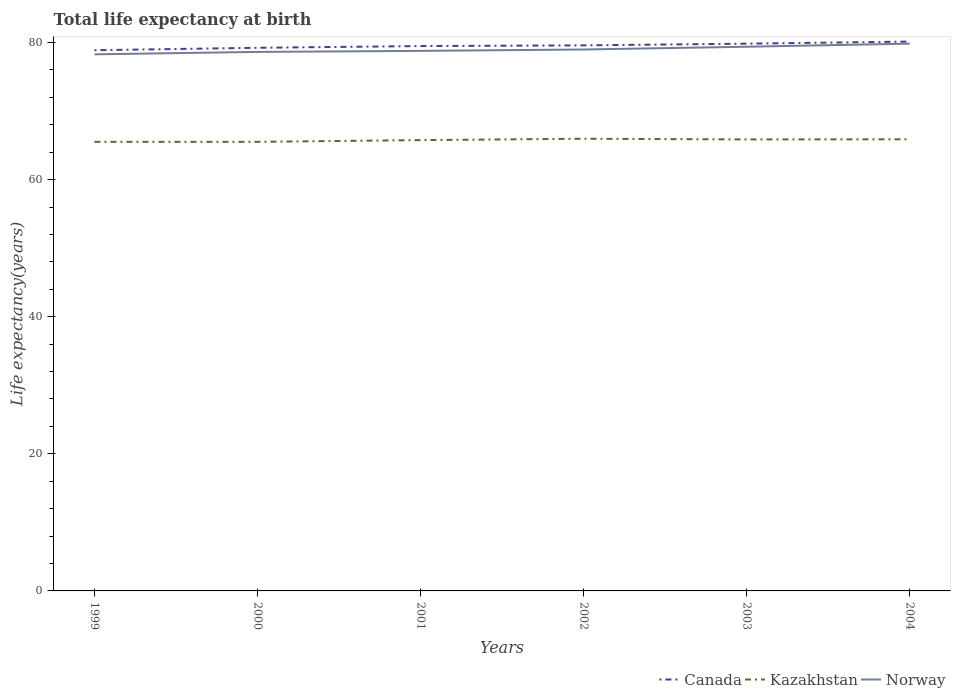Across all years, what is the maximum life expectancy at birth in in Kazakhstan?
Provide a succinct answer. 65.52. In which year was the life expectancy at birth in in Kazakhstan maximum?
Make the answer very short. 2000. What is the total life expectancy at birth in in Norway in the graph?
Provide a short and direct response. -0.15. What is the difference between the highest and the second highest life expectancy at birth in in Kazakhstan?
Your answer should be compact. 0.45. What is the difference between the highest and the lowest life expectancy at birth in in Kazakhstan?
Your response must be concise. 4. How many lines are there?
Your answer should be compact. 3. What is the difference between two consecutive major ticks on the Y-axis?
Make the answer very short. 20. Are the values on the major ticks of Y-axis written in scientific E-notation?
Ensure brevity in your answer.  No. Does the graph contain any zero values?
Your response must be concise. No. Does the graph contain grids?
Keep it short and to the point. No. How many legend labels are there?
Your response must be concise. 3. How are the legend labels stacked?
Offer a terse response. Horizontal. What is the title of the graph?
Make the answer very short. Total life expectancy at birth. Does "Korea (Republic)" appear as one of the legend labels in the graph?
Provide a succinct answer. No. What is the label or title of the Y-axis?
Make the answer very short. Life expectancy(years). What is the Life expectancy(years) of Canada in 1999?
Your answer should be compact. 78.88. What is the Life expectancy(years) in Kazakhstan in 1999?
Offer a very short reply. 65.52. What is the Life expectancy(years) of Norway in 1999?
Your answer should be compact. 78.28. What is the Life expectancy(years) in Canada in 2000?
Ensure brevity in your answer.  79.24. What is the Life expectancy(years) of Kazakhstan in 2000?
Offer a very short reply. 65.52. What is the Life expectancy(years) in Norway in 2000?
Make the answer very short. 78.63. What is the Life expectancy(years) in Canada in 2001?
Provide a succinct answer. 79.49. What is the Life expectancy(years) in Kazakhstan in 2001?
Offer a very short reply. 65.77. What is the Life expectancy(years) of Norway in 2001?
Your answer should be very brief. 78.79. What is the Life expectancy(years) of Canada in 2002?
Your response must be concise. 79.59. What is the Life expectancy(years) in Kazakhstan in 2002?
Ensure brevity in your answer.  65.97. What is the Life expectancy(years) in Norway in 2002?
Give a very brief answer. 78.99. What is the Life expectancy(years) of Canada in 2003?
Your answer should be compact. 79.84. What is the Life expectancy(years) in Kazakhstan in 2003?
Your response must be concise. 65.87. What is the Life expectancy(years) of Norway in 2003?
Your response must be concise. 79.39. What is the Life expectancy(years) in Canada in 2004?
Ensure brevity in your answer.  80.14. What is the Life expectancy(years) of Kazakhstan in 2004?
Offer a very short reply. 65.89. What is the Life expectancy(years) of Norway in 2004?
Provide a succinct answer. 79.84. Across all years, what is the maximum Life expectancy(years) of Canada?
Offer a terse response. 80.14. Across all years, what is the maximum Life expectancy(years) of Kazakhstan?
Offer a very short reply. 65.97. Across all years, what is the maximum Life expectancy(years) of Norway?
Your answer should be compact. 79.84. Across all years, what is the minimum Life expectancy(years) in Canada?
Provide a short and direct response. 78.88. Across all years, what is the minimum Life expectancy(years) in Kazakhstan?
Offer a terse response. 65.52. Across all years, what is the minimum Life expectancy(years) of Norway?
Ensure brevity in your answer.  78.28. What is the total Life expectancy(years) of Canada in the graph?
Offer a very short reply. 477.18. What is the total Life expectancy(years) of Kazakhstan in the graph?
Your answer should be very brief. 394.53. What is the total Life expectancy(years) of Norway in the graph?
Your response must be concise. 473.92. What is the difference between the Life expectancy(years) of Canada in 1999 and that in 2000?
Your answer should be compact. -0.35. What is the difference between the Life expectancy(years) of Kazakhstan in 1999 and that in 2000?
Keep it short and to the point. 0. What is the difference between the Life expectancy(years) in Norway in 1999 and that in 2000?
Provide a succinct answer. -0.35. What is the difference between the Life expectancy(years) in Canada in 1999 and that in 2001?
Your answer should be very brief. -0.6. What is the difference between the Life expectancy(years) of Kazakhstan in 1999 and that in 2001?
Make the answer very short. -0.25. What is the difference between the Life expectancy(years) in Norway in 1999 and that in 2001?
Offer a terse response. -0.5. What is the difference between the Life expectancy(years) of Canada in 1999 and that in 2002?
Make the answer very short. -0.71. What is the difference between the Life expectancy(years) of Kazakhstan in 1999 and that in 2002?
Provide a succinct answer. -0.45. What is the difference between the Life expectancy(years) in Norway in 1999 and that in 2002?
Give a very brief answer. -0.7. What is the difference between the Life expectancy(years) in Canada in 1999 and that in 2003?
Your answer should be compact. -0.96. What is the difference between the Life expectancy(years) in Kazakhstan in 1999 and that in 2003?
Your answer should be compact. -0.35. What is the difference between the Life expectancy(years) of Norway in 1999 and that in 2003?
Your answer should be compact. -1.11. What is the difference between the Life expectancy(years) of Canada in 1999 and that in 2004?
Ensure brevity in your answer.  -1.26. What is the difference between the Life expectancy(years) in Kazakhstan in 1999 and that in 2004?
Keep it short and to the point. -0.37. What is the difference between the Life expectancy(years) of Norway in 1999 and that in 2004?
Offer a terse response. -1.56. What is the difference between the Life expectancy(years) of Canada in 2000 and that in 2001?
Offer a terse response. -0.25. What is the difference between the Life expectancy(years) in Kazakhstan in 2000 and that in 2001?
Ensure brevity in your answer.  -0.25. What is the difference between the Life expectancy(years) of Norway in 2000 and that in 2001?
Ensure brevity in your answer.  -0.15. What is the difference between the Life expectancy(years) in Canada in 2000 and that in 2002?
Keep it short and to the point. -0.35. What is the difference between the Life expectancy(years) of Kazakhstan in 2000 and that in 2002?
Offer a very short reply. -0.45. What is the difference between the Life expectancy(years) in Norway in 2000 and that in 2002?
Keep it short and to the point. -0.35. What is the difference between the Life expectancy(years) in Canada in 2000 and that in 2003?
Ensure brevity in your answer.  -0.6. What is the difference between the Life expectancy(years) in Kazakhstan in 2000 and that in 2003?
Ensure brevity in your answer.  -0.35. What is the difference between the Life expectancy(years) in Norway in 2000 and that in 2003?
Offer a terse response. -0.76. What is the difference between the Life expectancy(years) of Canada in 2000 and that in 2004?
Provide a short and direct response. -0.9. What is the difference between the Life expectancy(years) of Kazakhstan in 2000 and that in 2004?
Keep it short and to the point. -0.37. What is the difference between the Life expectancy(years) of Norway in 2000 and that in 2004?
Ensure brevity in your answer.  -1.21. What is the difference between the Life expectancy(years) in Canada in 2001 and that in 2002?
Offer a very short reply. -0.1. What is the difference between the Life expectancy(years) in Norway in 2001 and that in 2002?
Your response must be concise. -0.2. What is the difference between the Life expectancy(years) of Canada in 2001 and that in 2003?
Give a very brief answer. -0.35. What is the difference between the Life expectancy(years) in Kazakhstan in 2001 and that in 2003?
Provide a succinct answer. -0.1. What is the difference between the Life expectancy(years) of Norway in 2001 and that in 2003?
Ensure brevity in your answer.  -0.6. What is the difference between the Life expectancy(years) in Canada in 2001 and that in 2004?
Provide a short and direct response. -0.65. What is the difference between the Life expectancy(years) of Kazakhstan in 2001 and that in 2004?
Give a very brief answer. -0.12. What is the difference between the Life expectancy(years) of Norway in 2001 and that in 2004?
Ensure brevity in your answer.  -1.06. What is the difference between the Life expectancy(years) in Canada in 2002 and that in 2003?
Keep it short and to the point. -0.25. What is the difference between the Life expectancy(years) of Kazakhstan in 2002 and that in 2003?
Offer a terse response. 0.1. What is the difference between the Life expectancy(years) in Norway in 2002 and that in 2003?
Ensure brevity in your answer.  -0.4. What is the difference between the Life expectancy(years) of Canada in 2002 and that in 2004?
Provide a short and direct response. -0.55. What is the difference between the Life expectancy(years) of Kazakhstan in 2002 and that in 2004?
Provide a succinct answer. 0.08. What is the difference between the Life expectancy(years) in Norway in 2002 and that in 2004?
Make the answer very short. -0.85. What is the difference between the Life expectancy(years) of Canada in 2003 and that in 2004?
Provide a succinct answer. -0.3. What is the difference between the Life expectancy(years) in Kazakhstan in 2003 and that in 2004?
Provide a succinct answer. -0.02. What is the difference between the Life expectancy(years) of Norway in 2003 and that in 2004?
Keep it short and to the point. -0.45. What is the difference between the Life expectancy(years) in Canada in 1999 and the Life expectancy(years) in Kazakhstan in 2000?
Provide a short and direct response. 13.37. What is the difference between the Life expectancy(years) in Canada in 1999 and the Life expectancy(years) in Norway in 2000?
Provide a short and direct response. 0.25. What is the difference between the Life expectancy(years) in Kazakhstan in 1999 and the Life expectancy(years) in Norway in 2000?
Ensure brevity in your answer.  -13.11. What is the difference between the Life expectancy(years) of Canada in 1999 and the Life expectancy(years) of Kazakhstan in 2001?
Provide a succinct answer. 13.11. What is the difference between the Life expectancy(years) of Canada in 1999 and the Life expectancy(years) of Norway in 2001?
Keep it short and to the point. 0.1. What is the difference between the Life expectancy(years) in Kazakhstan in 1999 and the Life expectancy(years) in Norway in 2001?
Provide a succinct answer. -13.27. What is the difference between the Life expectancy(years) in Canada in 1999 and the Life expectancy(years) in Kazakhstan in 2002?
Give a very brief answer. 12.91. What is the difference between the Life expectancy(years) in Canada in 1999 and the Life expectancy(years) in Norway in 2002?
Offer a terse response. -0.1. What is the difference between the Life expectancy(years) in Kazakhstan in 1999 and the Life expectancy(years) in Norway in 2002?
Provide a short and direct response. -13.47. What is the difference between the Life expectancy(years) in Canada in 1999 and the Life expectancy(years) in Kazakhstan in 2003?
Offer a very short reply. 13.02. What is the difference between the Life expectancy(years) of Canada in 1999 and the Life expectancy(years) of Norway in 2003?
Keep it short and to the point. -0.51. What is the difference between the Life expectancy(years) of Kazakhstan in 1999 and the Life expectancy(years) of Norway in 2003?
Provide a succinct answer. -13.87. What is the difference between the Life expectancy(years) in Canada in 1999 and the Life expectancy(years) in Kazakhstan in 2004?
Provide a succinct answer. 13. What is the difference between the Life expectancy(years) in Canada in 1999 and the Life expectancy(years) in Norway in 2004?
Provide a short and direct response. -0.96. What is the difference between the Life expectancy(years) in Kazakhstan in 1999 and the Life expectancy(years) in Norway in 2004?
Ensure brevity in your answer.  -14.32. What is the difference between the Life expectancy(years) of Canada in 2000 and the Life expectancy(years) of Kazakhstan in 2001?
Keep it short and to the point. 13.47. What is the difference between the Life expectancy(years) in Canada in 2000 and the Life expectancy(years) in Norway in 2001?
Make the answer very short. 0.45. What is the difference between the Life expectancy(years) of Kazakhstan in 2000 and the Life expectancy(years) of Norway in 2001?
Your answer should be compact. -13.27. What is the difference between the Life expectancy(years) in Canada in 2000 and the Life expectancy(years) in Kazakhstan in 2002?
Ensure brevity in your answer.  13.27. What is the difference between the Life expectancy(years) in Canada in 2000 and the Life expectancy(years) in Norway in 2002?
Provide a succinct answer. 0.25. What is the difference between the Life expectancy(years) in Kazakhstan in 2000 and the Life expectancy(years) in Norway in 2002?
Give a very brief answer. -13.47. What is the difference between the Life expectancy(years) in Canada in 2000 and the Life expectancy(years) in Kazakhstan in 2003?
Make the answer very short. 13.37. What is the difference between the Life expectancy(years) in Canada in 2000 and the Life expectancy(years) in Norway in 2003?
Provide a short and direct response. -0.15. What is the difference between the Life expectancy(years) of Kazakhstan in 2000 and the Life expectancy(years) of Norway in 2003?
Keep it short and to the point. -13.87. What is the difference between the Life expectancy(years) of Canada in 2000 and the Life expectancy(years) of Kazakhstan in 2004?
Keep it short and to the point. 13.35. What is the difference between the Life expectancy(years) of Canada in 2000 and the Life expectancy(years) of Norway in 2004?
Offer a terse response. -0.6. What is the difference between the Life expectancy(years) of Kazakhstan in 2000 and the Life expectancy(years) of Norway in 2004?
Provide a short and direct response. -14.32. What is the difference between the Life expectancy(years) of Canada in 2001 and the Life expectancy(years) of Kazakhstan in 2002?
Offer a very short reply. 13.52. What is the difference between the Life expectancy(years) of Canada in 2001 and the Life expectancy(years) of Norway in 2002?
Make the answer very short. 0.5. What is the difference between the Life expectancy(years) in Kazakhstan in 2001 and the Life expectancy(years) in Norway in 2002?
Keep it short and to the point. -13.22. What is the difference between the Life expectancy(years) of Canada in 2001 and the Life expectancy(years) of Kazakhstan in 2003?
Offer a very short reply. 13.62. What is the difference between the Life expectancy(years) of Canada in 2001 and the Life expectancy(years) of Norway in 2003?
Offer a terse response. 0.1. What is the difference between the Life expectancy(years) of Kazakhstan in 2001 and the Life expectancy(years) of Norway in 2003?
Ensure brevity in your answer.  -13.62. What is the difference between the Life expectancy(years) in Canada in 2001 and the Life expectancy(years) in Norway in 2004?
Give a very brief answer. -0.35. What is the difference between the Life expectancy(years) in Kazakhstan in 2001 and the Life expectancy(years) in Norway in 2004?
Offer a very short reply. -14.07. What is the difference between the Life expectancy(years) of Canada in 2002 and the Life expectancy(years) of Kazakhstan in 2003?
Your response must be concise. 13.72. What is the difference between the Life expectancy(years) of Canada in 2002 and the Life expectancy(years) of Norway in 2003?
Provide a succinct answer. 0.2. What is the difference between the Life expectancy(years) of Kazakhstan in 2002 and the Life expectancy(years) of Norway in 2003?
Keep it short and to the point. -13.42. What is the difference between the Life expectancy(years) of Canada in 2002 and the Life expectancy(years) of Kazakhstan in 2004?
Offer a very short reply. 13.7. What is the difference between the Life expectancy(years) in Canada in 2002 and the Life expectancy(years) in Norway in 2004?
Your response must be concise. -0.25. What is the difference between the Life expectancy(years) in Kazakhstan in 2002 and the Life expectancy(years) in Norway in 2004?
Offer a terse response. -13.87. What is the difference between the Life expectancy(years) of Canada in 2003 and the Life expectancy(years) of Kazakhstan in 2004?
Make the answer very short. 13.95. What is the difference between the Life expectancy(years) of Canada in 2003 and the Life expectancy(years) of Norway in 2004?
Offer a very short reply. -0. What is the difference between the Life expectancy(years) of Kazakhstan in 2003 and the Life expectancy(years) of Norway in 2004?
Your answer should be compact. -13.98. What is the average Life expectancy(years) of Canada per year?
Your answer should be compact. 79.53. What is the average Life expectancy(years) in Kazakhstan per year?
Offer a very short reply. 65.75. What is the average Life expectancy(years) in Norway per year?
Offer a terse response. 78.99. In the year 1999, what is the difference between the Life expectancy(years) in Canada and Life expectancy(years) in Kazakhstan?
Make the answer very short. 13.36. In the year 1999, what is the difference between the Life expectancy(years) in Canada and Life expectancy(years) in Norway?
Give a very brief answer. 0.6. In the year 1999, what is the difference between the Life expectancy(years) of Kazakhstan and Life expectancy(years) of Norway?
Offer a terse response. -12.76. In the year 2000, what is the difference between the Life expectancy(years) in Canada and Life expectancy(years) in Kazakhstan?
Give a very brief answer. 13.72. In the year 2000, what is the difference between the Life expectancy(years) of Canada and Life expectancy(years) of Norway?
Offer a very short reply. 0.6. In the year 2000, what is the difference between the Life expectancy(years) in Kazakhstan and Life expectancy(years) in Norway?
Offer a very short reply. -13.12. In the year 2001, what is the difference between the Life expectancy(years) in Canada and Life expectancy(years) in Kazakhstan?
Provide a succinct answer. 13.72. In the year 2001, what is the difference between the Life expectancy(years) in Canada and Life expectancy(years) in Norway?
Give a very brief answer. 0.7. In the year 2001, what is the difference between the Life expectancy(years) of Kazakhstan and Life expectancy(years) of Norway?
Make the answer very short. -13.02. In the year 2002, what is the difference between the Life expectancy(years) of Canada and Life expectancy(years) of Kazakhstan?
Your answer should be very brief. 13.62. In the year 2002, what is the difference between the Life expectancy(years) in Canada and Life expectancy(years) in Norway?
Offer a very short reply. 0.6. In the year 2002, what is the difference between the Life expectancy(years) of Kazakhstan and Life expectancy(years) of Norway?
Your answer should be compact. -13.02. In the year 2003, what is the difference between the Life expectancy(years) of Canada and Life expectancy(years) of Kazakhstan?
Your answer should be very brief. 13.97. In the year 2003, what is the difference between the Life expectancy(years) of Canada and Life expectancy(years) of Norway?
Offer a very short reply. 0.45. In the year 2003, what is the difference between the Life expectancy(years) of Kazakhstan and Life expectancy(years) of Norway?
Offer a very short reply. -13.52. In the year 2004, what is the difference between the Life expectancy(years) in Canada and Life expectancy(years) in Kazakhstan?
Your answer should be very brief. 14.25. In the year 2004, what is the difference between the Life expectancy(years) in Canada and Life expectancy(years) in Norway?
Your response must be concise. 0.3. In the year 2004, what is the difference between the Life expectancy(years) of Kazakhstan and Life expectancy(years) of Norway?
Ensure brevity in your answer.  -13.95. What is the ratio of the Life expectancy(years) in Kazakhstan in 1999 to that in 2000?
Give a very brief answer. 1. What is the ratio of the Life expectancy(years) in Canada in 1999 to that in 2001?
Offer a very short reply. 0.99. What is the ratio of the Life expectancy(years) in Norway in 1999 to that in 2001?
Provide a succinct answer. 0.99. What is the ratio of the Life expectancy(years) in Norway in 1999 to that in 2002?
Offer a terse response. 0.99. What is the ratio of the Life expectancy(years) of Norway in 1999 to that in 2003?
Give a very brief answer. 0.99. What is the ratio of the Life expectancy(years) of Canada in 1999 to that in 2004?
Your answer should be very brief. 0.98. What is the ratio of the Life expectancy(years) of Kazakhstan in 1999 to that in 2004?
Your answer should be compact. 0.99. What is the ratio of the Life expectancy(years) in Norway in 1999 to that in 2004?
Your answer should be very brief. 0.98. What is the ratio of the Life expectancy(years) in Canada in 2000 to that in 2001?
Give a very brief answer. 1. What is the ratio of the Life expectancy(years) in Kazakhstan in 2000 to that in 2002?
Ensure brevity in your answer.  0.99. What is the ratio of the Life expectancy(years) of Norway in 2000 to that in 2002?
Keep it short and to the point. 1. What is the ratio of the Life expectancy(years) of Canada in 2000 to that in 2003?
Provide a short and direct response. 0.99. What is the ratio of the Life expectancy(years) in Canada in 2000 to that in 2004?
Make the answer very short. 0.99. What is the ratio of the Life expectancy(years) in Kazakhstan in 2000 to that in 2004?
Your response must be concise. 0.99. What is the ratio of the Life expectancy(years) in Norway in 2000 to that in 2004?
Keep it short and to the point. 0.98. What is the ratio of the Life expectancy(years) in Canada in 2001 to that in 2003?
Your response must be concise. 1. What is the ratio of the Life expectancy(years) in Kazakhstan in 2001 to that in 2003?
Your answer should be very brief. 1. What is the ratio of the Life expectancy(years) in Kazakhstan in 2001 to that in 2004?
Give a very brief answer. 1. What is the ratio of the Life expectancy(years) of Norway in 2001 to that in 2004?
Your answer should be very brief. 0.99. What is the ratio of the Life expectancy(years) of Canada in 2002 to that in 2003?
Make the answer very short. 1. What is the ratio of the Life expectancy(years) in Kazakhstan in 2002 to that in 2004?
Give a very brief answer. 1. What is the ratio of the Life expectancy(years) of Norway in 2002 to that in 2004?
Provide a succinct answer. 0.99. What is the ratio of the Life expectancy(years) of Kazakhstan in 2003 to that in 2004?
Offer a terse response. 1. What is the difference between the highest and the second highest Life expectancy(years) of Canada?
Keep it short and to the point. 0.3. What is the difference between the highest and the second highest Life expectancy(years) of Kazakhstan?
Offer a very short reply. 0.08. What is the difference between the highest and the second highest Life expectancy(years) in Norway?
Provide a succinct answer. 0.45. What is the difference between the highest and the lowest Life expectancy(years) in Canada?
Provide a succinct answer. 1.26. What is the difference between the highest and the lowest Life expectancy(years) of Kazakhstan?
Give a very brief answer. 0.45. What is the difference between the highest and the lowest Life expectancy(years) in Norway?
Provide a short and direct response. 1.56. 